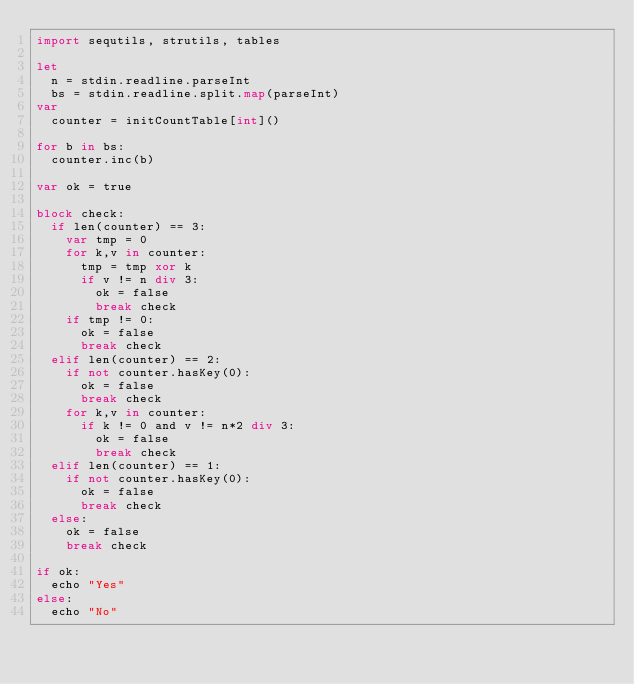<code> <loc_0><loc_0><loc_500><loc_500><_Nim_>import sequtils, strutils, tables

let
  n = stdin.readline.parseInt
  bs = stdin.readline.split.map(parseInt)
var
  counter = initCountTable[int]()

for b in bs:
  counter.inc(b)

var ok = true

block check:
  if len(counter) == 3:
    var tmp = 0
    for k,v in counter:
      tmp = tmp xor k
      if v != n div 3:
        ok = false
        break check
    if tmp != 0:
      ok = false
      break check
  elif len(counter) == 2:
    if not counter.hasKey(0):
      ok = false
      break check
    for k,v in counter:
      if k != 0 and v != n*2 div 3:
        ok = false
        break check
  elif len(counter) == 1:
    if not counter.hasKey(0):
      ok = false
      break check
  else:
    ok = false
    break check

if ok:
  echo "Yes"
else:
  echo "No"
</code> 